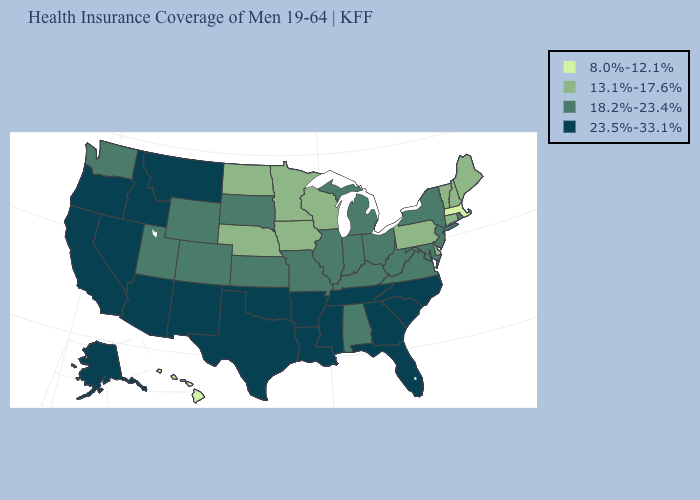What is the lowest value in the West?
Write a very short answer. 8.0%-12.1%. Does Massachusetts have the same value as Hawaii?
Keep it brief. Yes. What is the value of Illinois?
Concise answer only. 18.2%-23.4%. Among the states that border West Virginia , does Pennsylvania have the lowest value?
Write a very short answer. Yes. What is the value of Rhode Island?
Concise answer only. 18.2%-23.4%. Does New Jersey have the highest value in the Northeast?
Be succinct. Yes. How many symbols are there in the legend?
Quick response, please. 4. What is the highest value in the USA?
Answer briefly. 23.5%-33.1%. Does Virginia have a higher value than New Hampshire?
Quick response, please. Yes. Name the states that have a value in the range 8.0%-12.1%?
Concise answer only. Hawaii, Massachusetts. Among the states that border California , which have the lowest value?
Be succinct. Arizona, Nevada, Oregon. Among the states that border New York , which have the highest value?
Give a very brief answer. New Jersey. What is the value of South Carolina?
Concise answer only. 23.5%-33.1%. Name the states that have a value in the range 23.5%-33.1%?
Write a very short answer. Alaska, Arizona, Arkansas, California, Florida, Georgia, Idaho, Louisiana, Mississippi, Montana, Nevada, New Mexico, North Carolina, Oklahoma, Oregon, South Carolina, Tennessee, Texas. Name the states that have a value in the range 13.1%-17.6%?
Concise answer only. Connecticut, Delaware, Iowa, Maine, Minnesota, Nebraska, New Hampshire, North Dakota, Pennsylvania, Vermont, Wisconsin. 